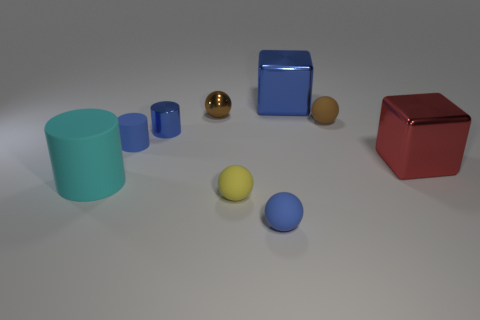Subtract all rubber spheres. How many spheres are left? 1 Subtract all blue cylinders. How many cylinders are left? 1 Subtract 1 cylinders. How many cylinders are left? 2 Subtract all brown balls. How many blue cubes are left? 1 Subtract all tiny yellow rubber spheres. Subtract all red objects. How many objects are left? 7 Add 2 large red shiny things. How many large red shiny things are left? 3 Add 6 big metallic blocks. How many big metallic blocks exist? 8 Subtract 0 gray cubes. How many objects are left? 9 Subtract all blocks. How many objects are left? 7 Subtract all cyan cylinders. Subtract all yellow spheres. How many cylinders are left? 2 